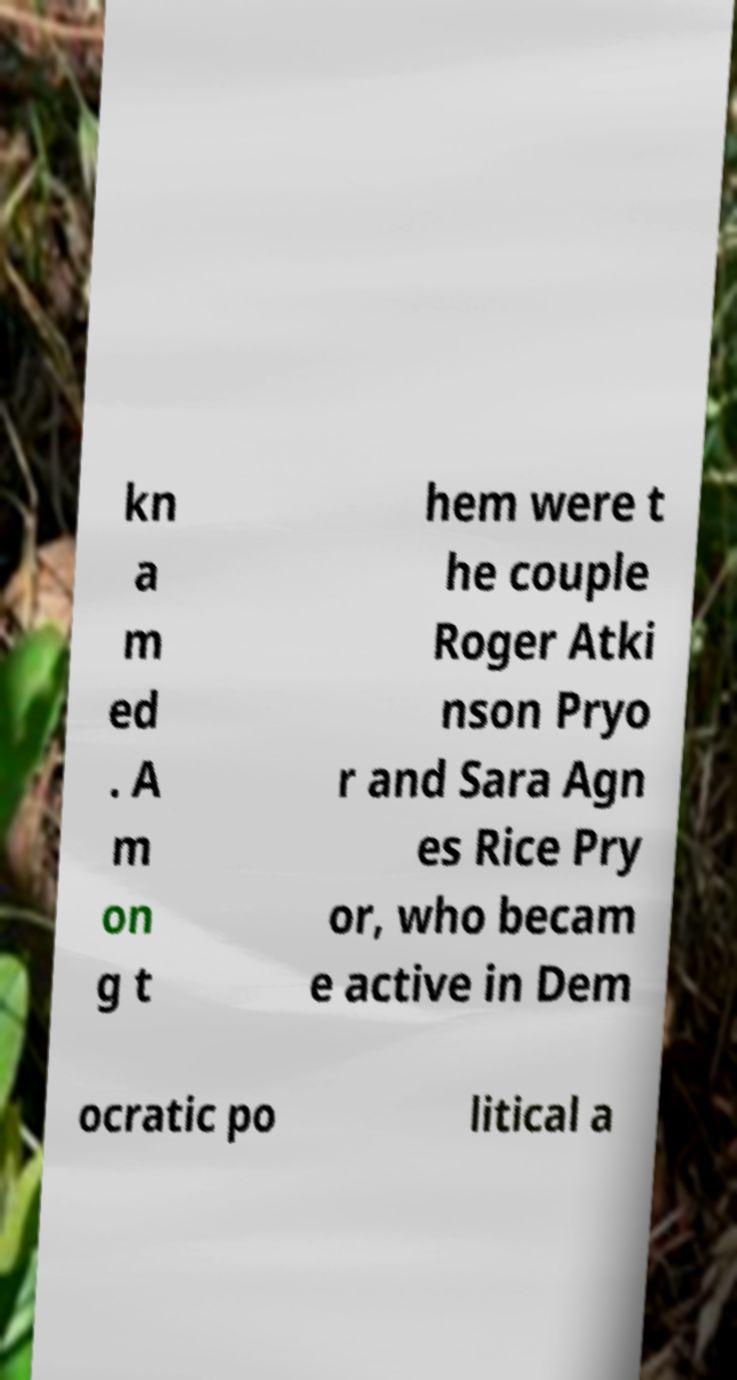Can you read and provide the text displayed in the image?This photo seems to have some interesting text. Can you extract and type it out for me? kn a m ed . A m on g t hem were t he couple Roger Atki nson Pryo r and Sara Agn es Rice Pry or, who becam e active in Dem ocratic po litical a 